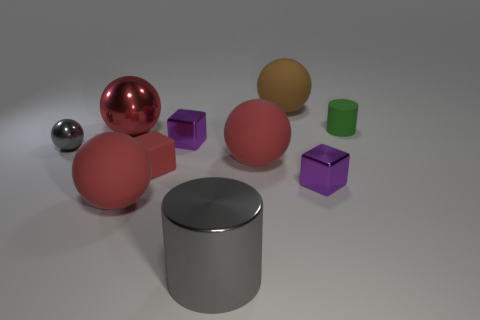The tiny block that is right of the cylinder that is in front of the tiny matte cylinder is made of what material?
Offer a very short reply. Metal. How many large things are either gray metallic balls or red cubes?
Keep it short and to the point. 0. How big is the red block?
Provide a succinct answer. Small. Are there more large brown matte objects that are behind the rubber cylinder than small green cylinders?
Your response must be concise. No. Are there the same number of objects in front of the rubber cylinder and gray spheres that are in front of the gray metal sphere?
Make the answer very short. No. There is a shiny object that is in front of the red cube and behind the large gray metal cylinder; what is its color?
Offer a terse response. Purple. Is there anything else that has the same size as the gray metal ball?
Offer a very short reply. Yes. Are there more gray objects that are right of the red rubber cube than matte things that are to the right of the gray cylinder?
Keep it short and to the point. No. There is a metallic object to the right of the brown thing; is it the same size as the brown thing?
Provide a short and direct response. No. How many objects are in front of the big red ball in front of the tiny purple cube that is right of the large cylinder?
Give a very brief answer. 1. 